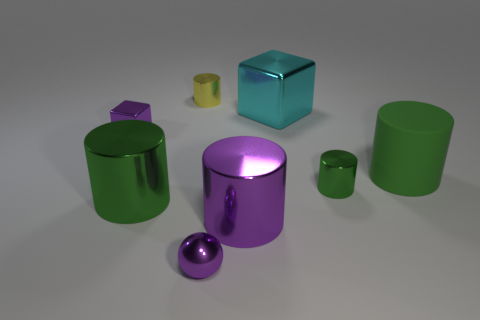Subtract all small cylinders. How many cylinders are left? 3 Subtract all cyan cubes. How many cubes are left? 1 Add 2 green shiny objects. How many objects exist? 10 Subtract 1 cubes. How many cubes are left? 1 Subtract 0 yellow cubes. How many objects are left? 8 Subtract all spheres. How many objects are left? 7 Subtract all yellow cylinders. Subtract all yellow cubes. How many cylinders are left? 4 Subtract all brown cylinders. How many purple blocks are left? 1 Subtract all large cyan cubes. Subtract all big cyan things. How many objects are left? 6 Add 4 purple blocks. How many purple blocks are left? 5 